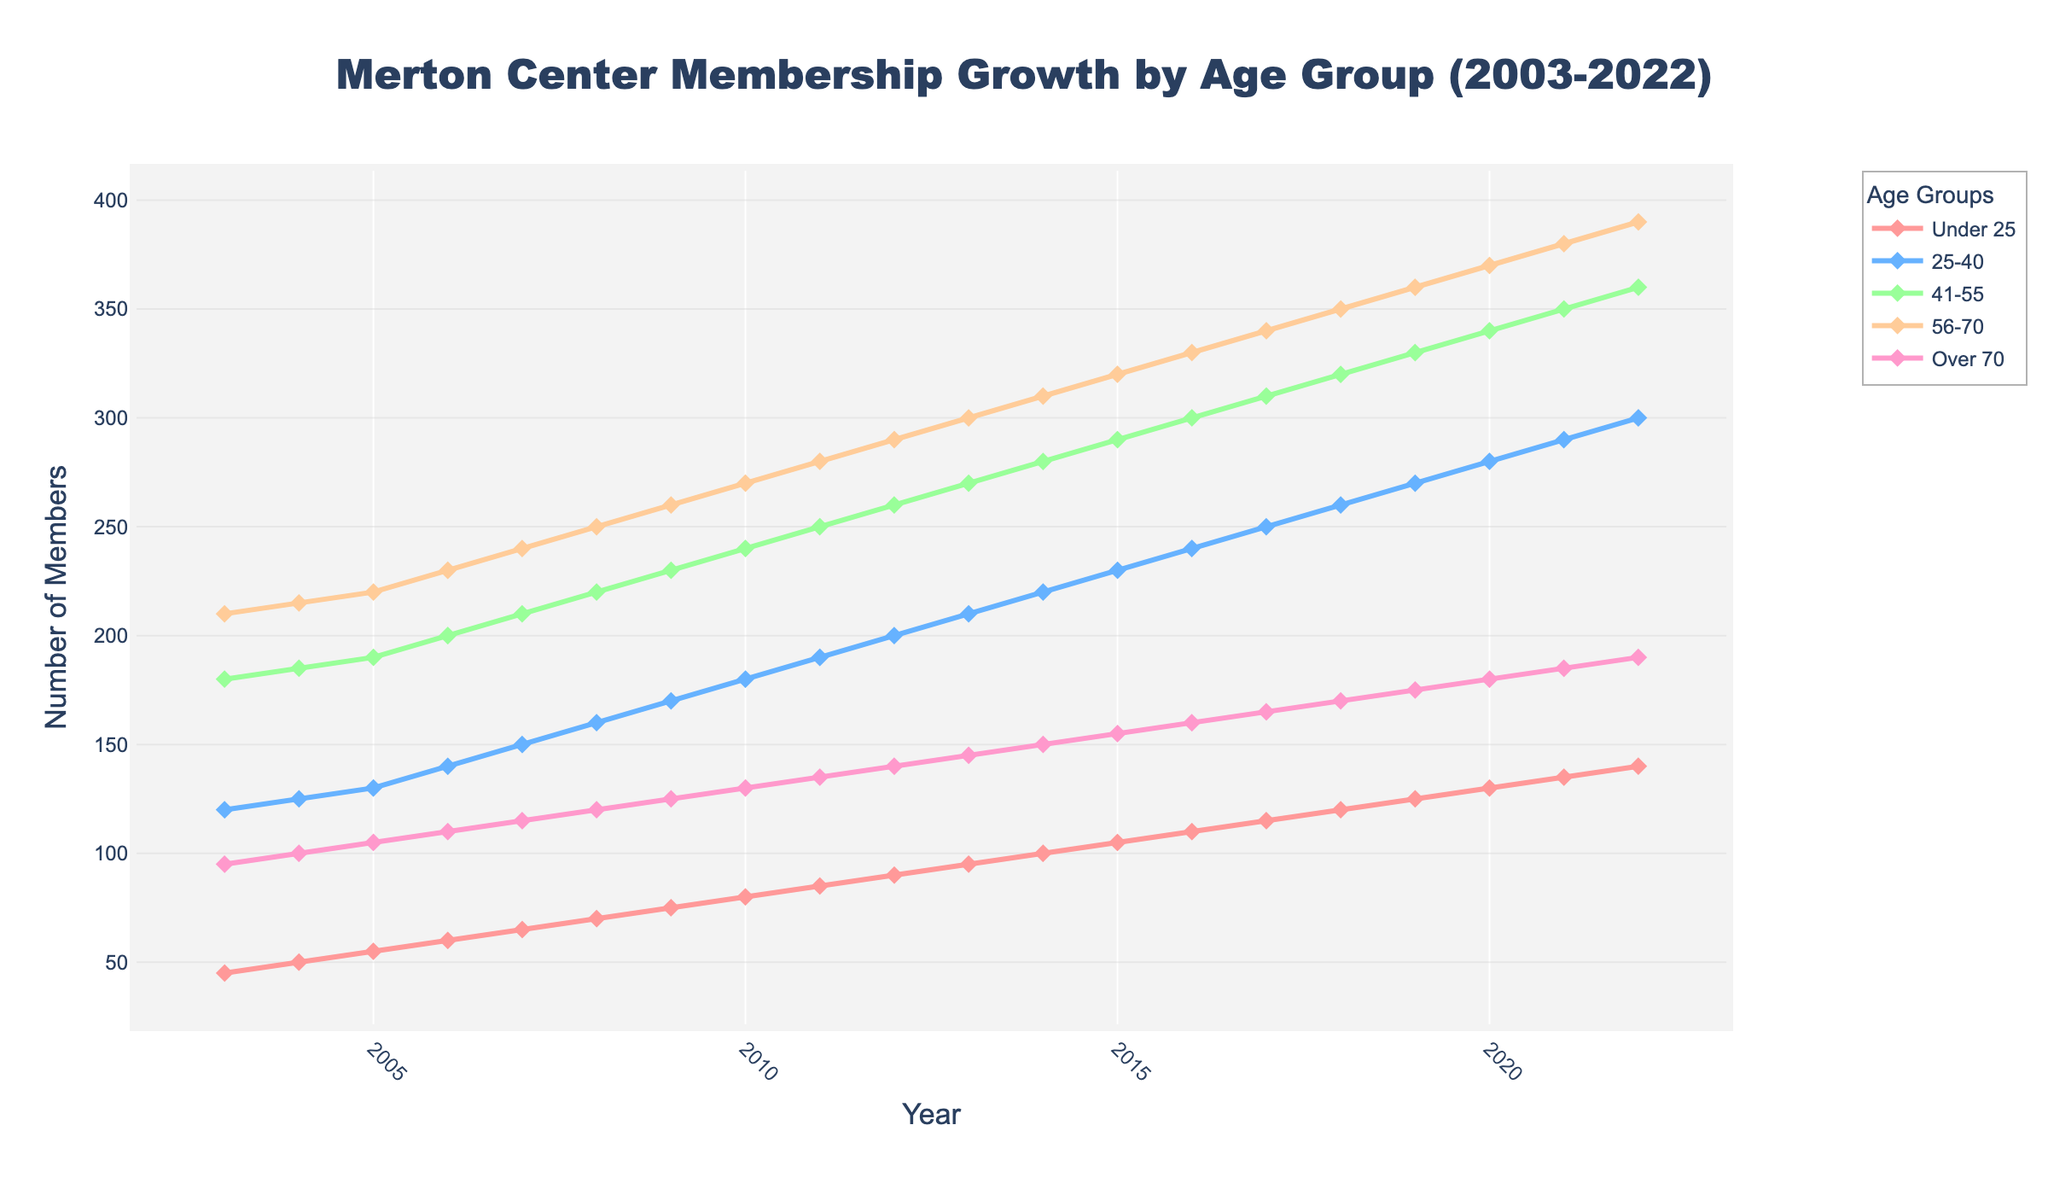What's the total number of members in 2006? To find the total number of members in 2006, sum the memberships of all the age groups for that year: Under 25 (60) + 25-40 (140) + 41-55 (200) + 56-70 (230) + Over 70 (110) = 740
Answer: 740 Which age group showed the highest growth from 2003 to 2022? Calculate the difference in membership for each age group from 2003 to 2022. Under 25: 140 - 45 = 95, 25-40: 300 - 120 = 180, 41-55: 360 - 180 = 180 , 56-70: 390 - 210 = 180, Over 70: 190 - 95 = 95. The highest growth is observed in the 25-40, 41-55, and 56-70 age groups, each with an increase of 180 members
Answer: 25-40, 41-55, 56-70 In which year did the Under 25 age group first surpass 100 members? Identify the year when the Under 25 membership first exceeds 100. This occurs in 2014
Answer: 2014 How did the membership of the 56-70 age group change between 2010 and 2015? Look at the membership values for the 56-70 age group in 2010 (270) and 2015 (320). The change is 320 - 270 = 50 members
Answer: increased by 50 Which age group consistently has the highest membership throughout the years? Compare the membership numbers across years for each age group. The 56-70 age group consistently has the highest membership each year
Answer: 56-70 By how much did the membership of the Over 70 age group increase from 2010 to 2020? The membership for the Over 70 age group in 2010 is 130, and in 2020, it is 180. The increase is 180 - 130 = 50 members
Answer: 50 What is the average number of members for the 25-40 age group over the 20 years? Sum the membership numbers for the 25-40 age group across all years and divide by 20. The total is 125+130+140+150+160+170+180+190+200+210+220+230+240+250+260+270+280+290+300 = 4395. So the average is 4395 / 20 = 219.75
Answer: 219.75 During which years did the membership for the 41-55 age group grow the most? Look at the yearly increments in membership for the 41-55 age group. The largest single-year increment is from 2006 to 2007, changing from 200 to 210 (10 members), but this is consistent throughout the years with an increase of 10 members each year
Answer: from 2006 to 2007 and every year with 10 What color represents the Under 25 age group in the plot? From the code, Under 25 is the first age group with the color specified as #FF9999, which is red
Answer: red How many members were there in total in 2015 for all age groups combined? Sum the membership numbers for all age groups in 2015: Under 25 (105) + 25-40 (230) + 41-55 (290) + 56-70 (320) + Over 70 (155) = 1100
Answer: 1100 